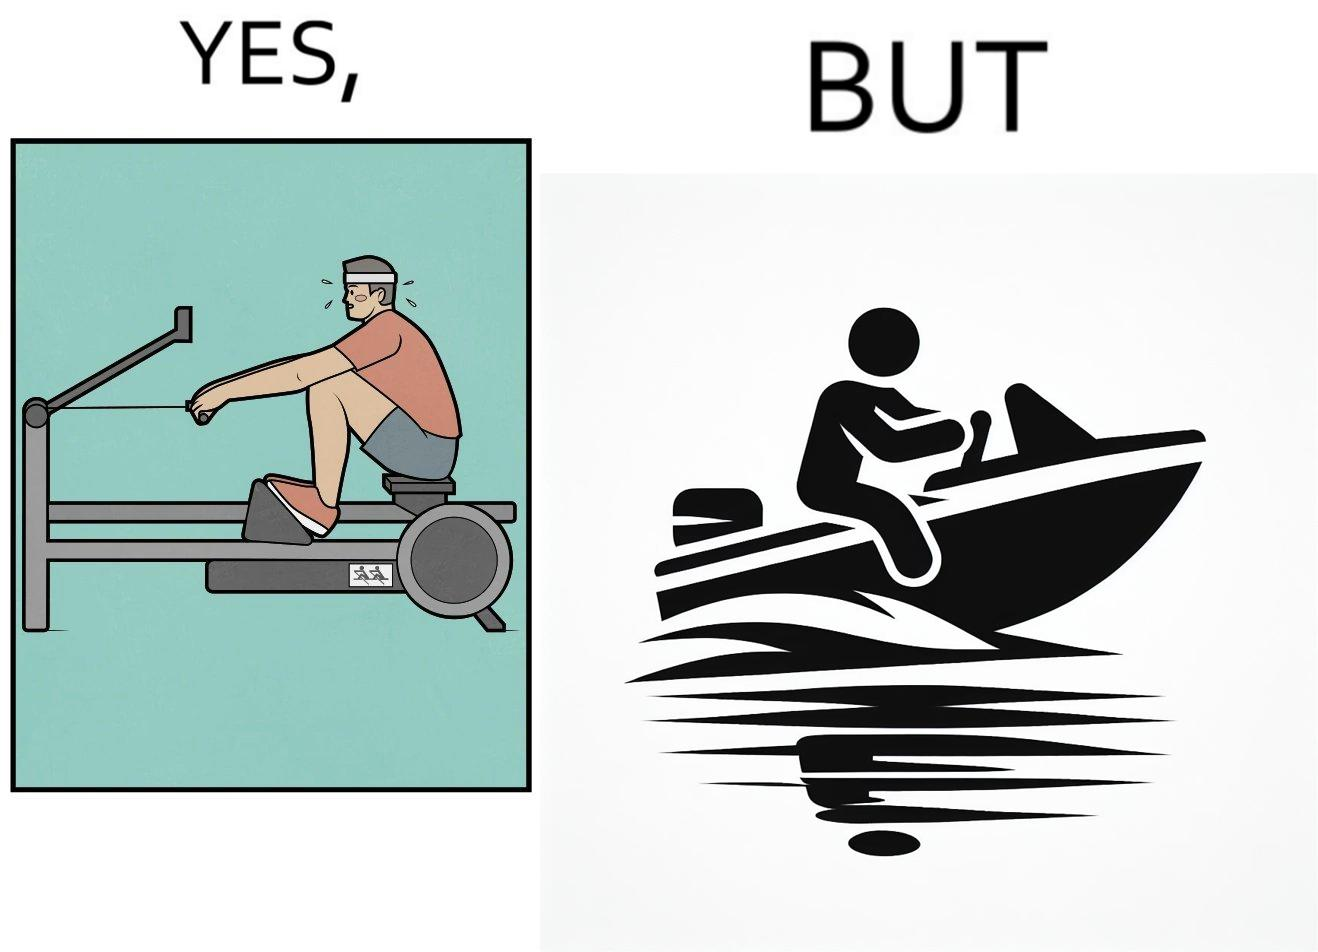Is this a satirical image? Yes, this image is satirical. 